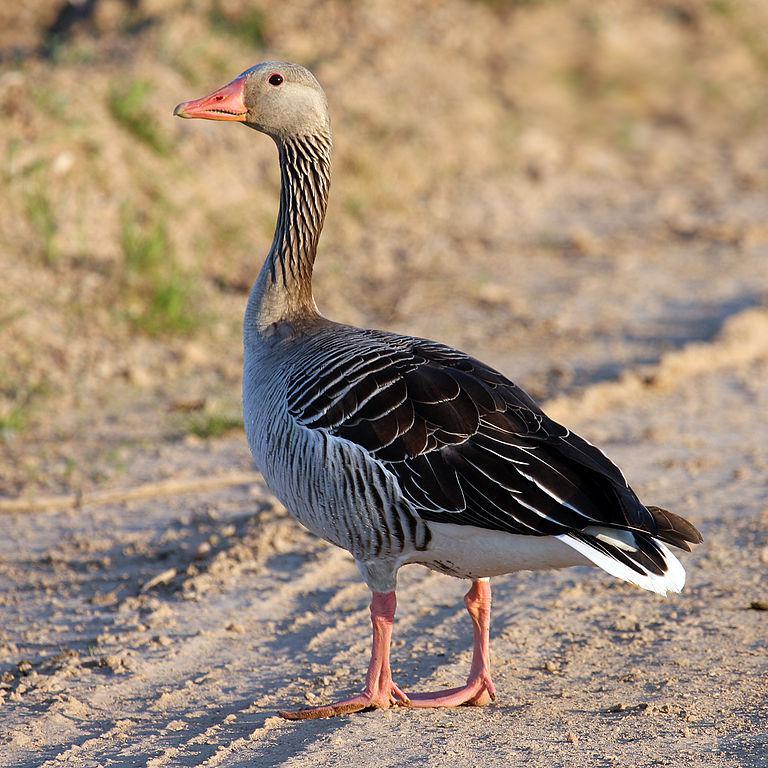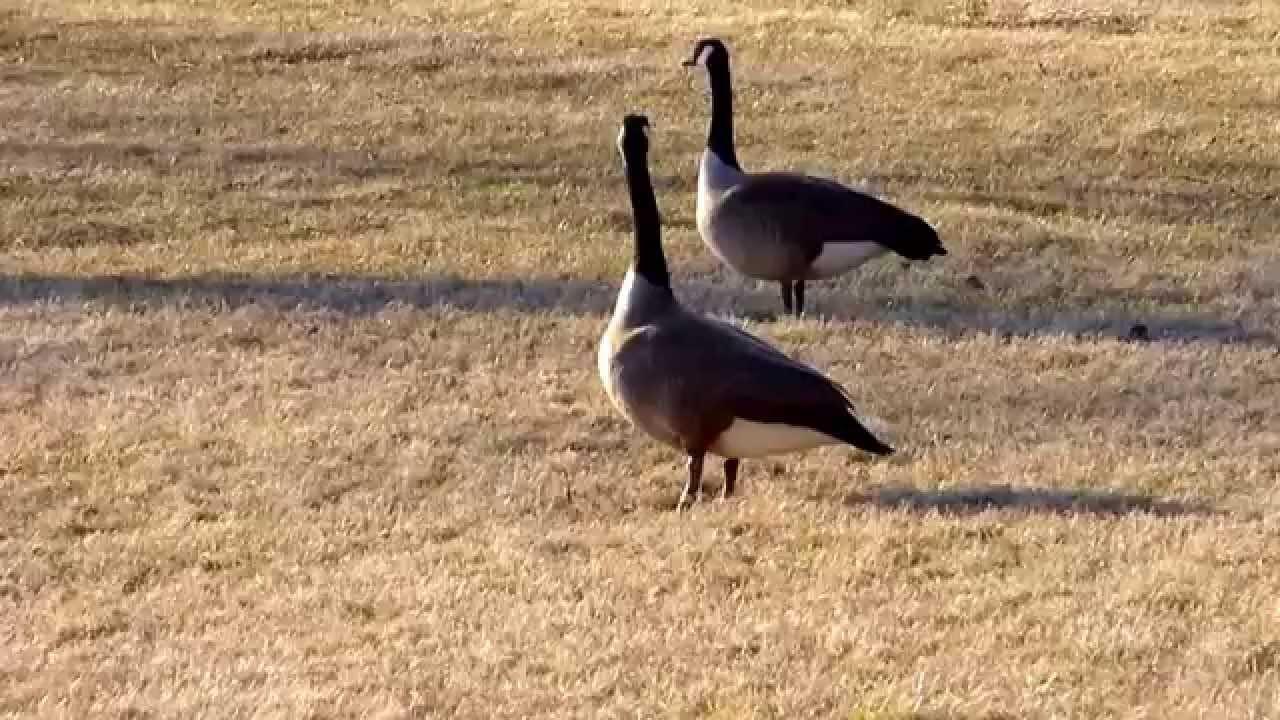The first image is the image on the left, the second image is the image on the right. Given the left and right images, does the statement "There are two birds in the picture on the right." hold true? Answer yes or no. Yes. 